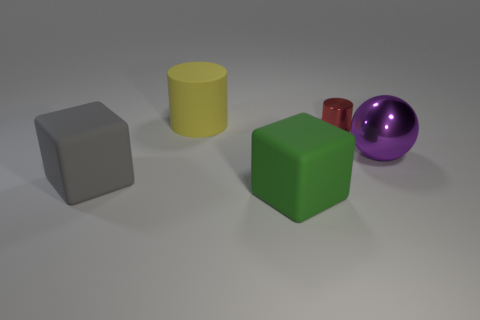What texture differences can you observe among the objects? The texture differences are subtle in the image, but the yellow cylinder seems to have a matte finish, while the purple ball appears metallic with a reflective surface, showcasing both diffuse and specular highlights. 